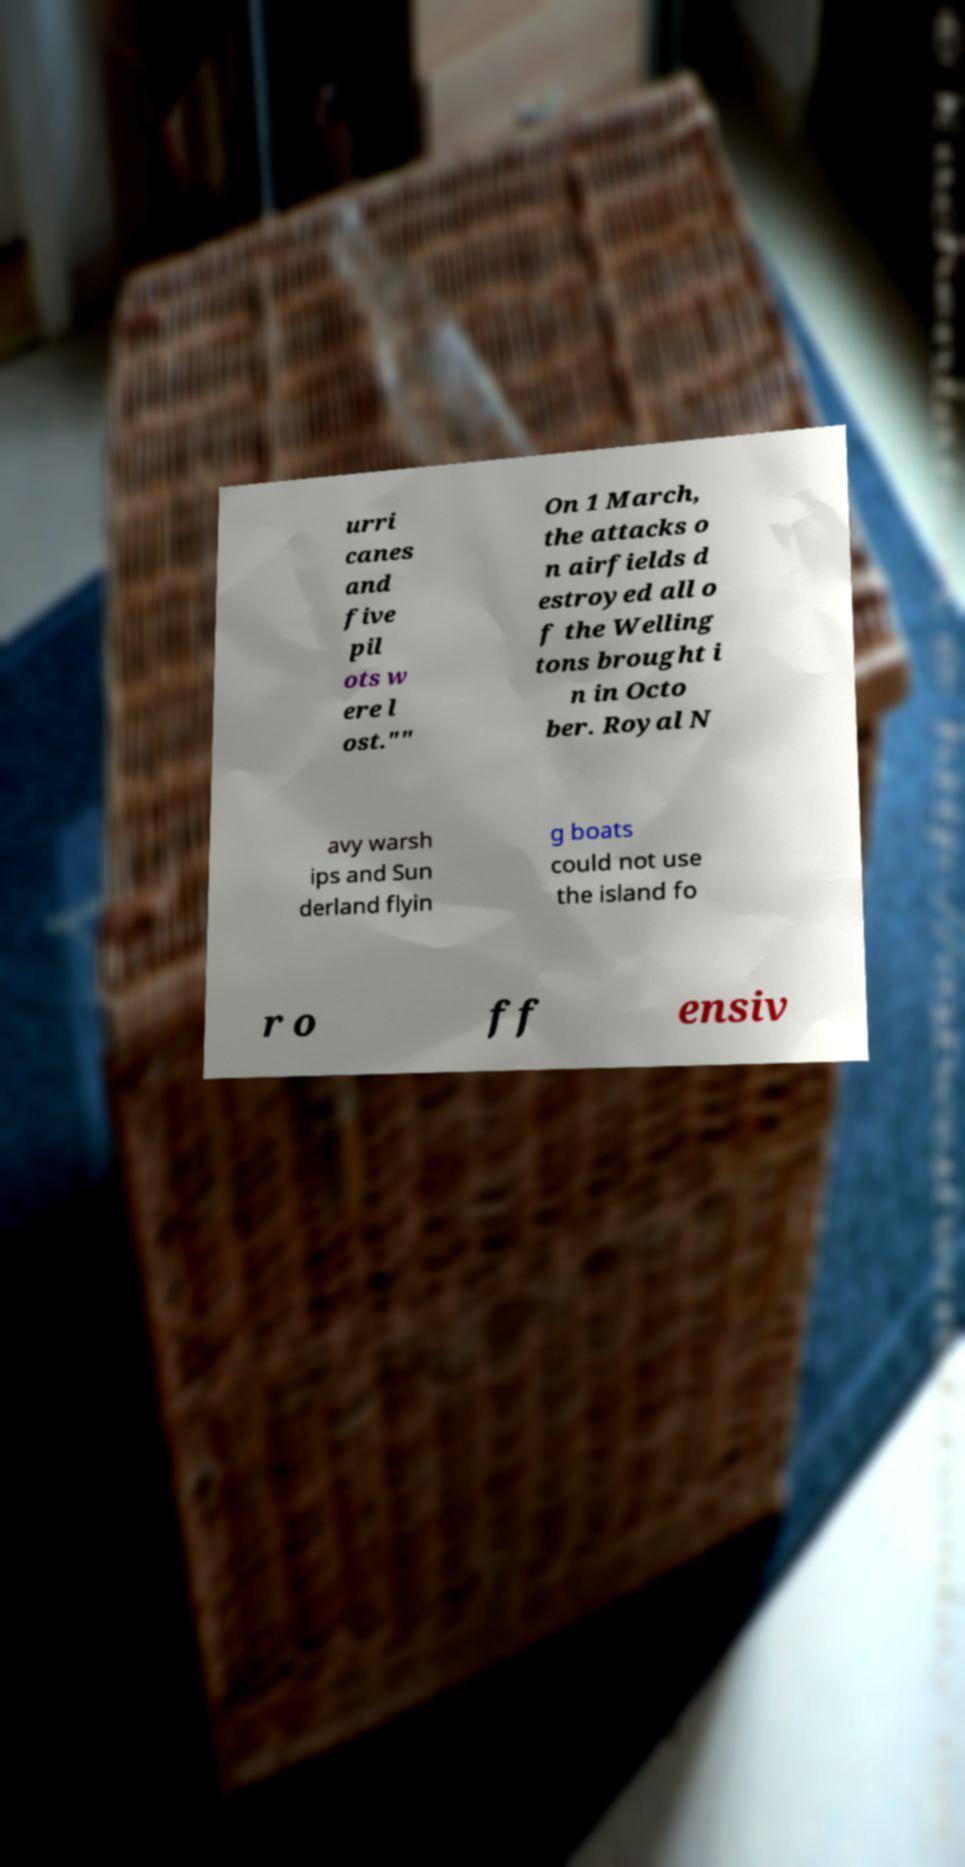Can you accurately transcribe the text from the provided image for me? urri canes and five pil ots w ere l ost."" On 1 March, the attacks o n airfields d estroyed all o f the Welling tons brought i n in Octo ber. Royal N avy warsh ips and Sun derland flyin g boats could not use the island fo r o ff ensiv 